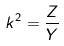<formula> <loc_0><loc_0><loc_500><loc_500>k ^ { 2 } = \frac { Z } { Y }</formula> 